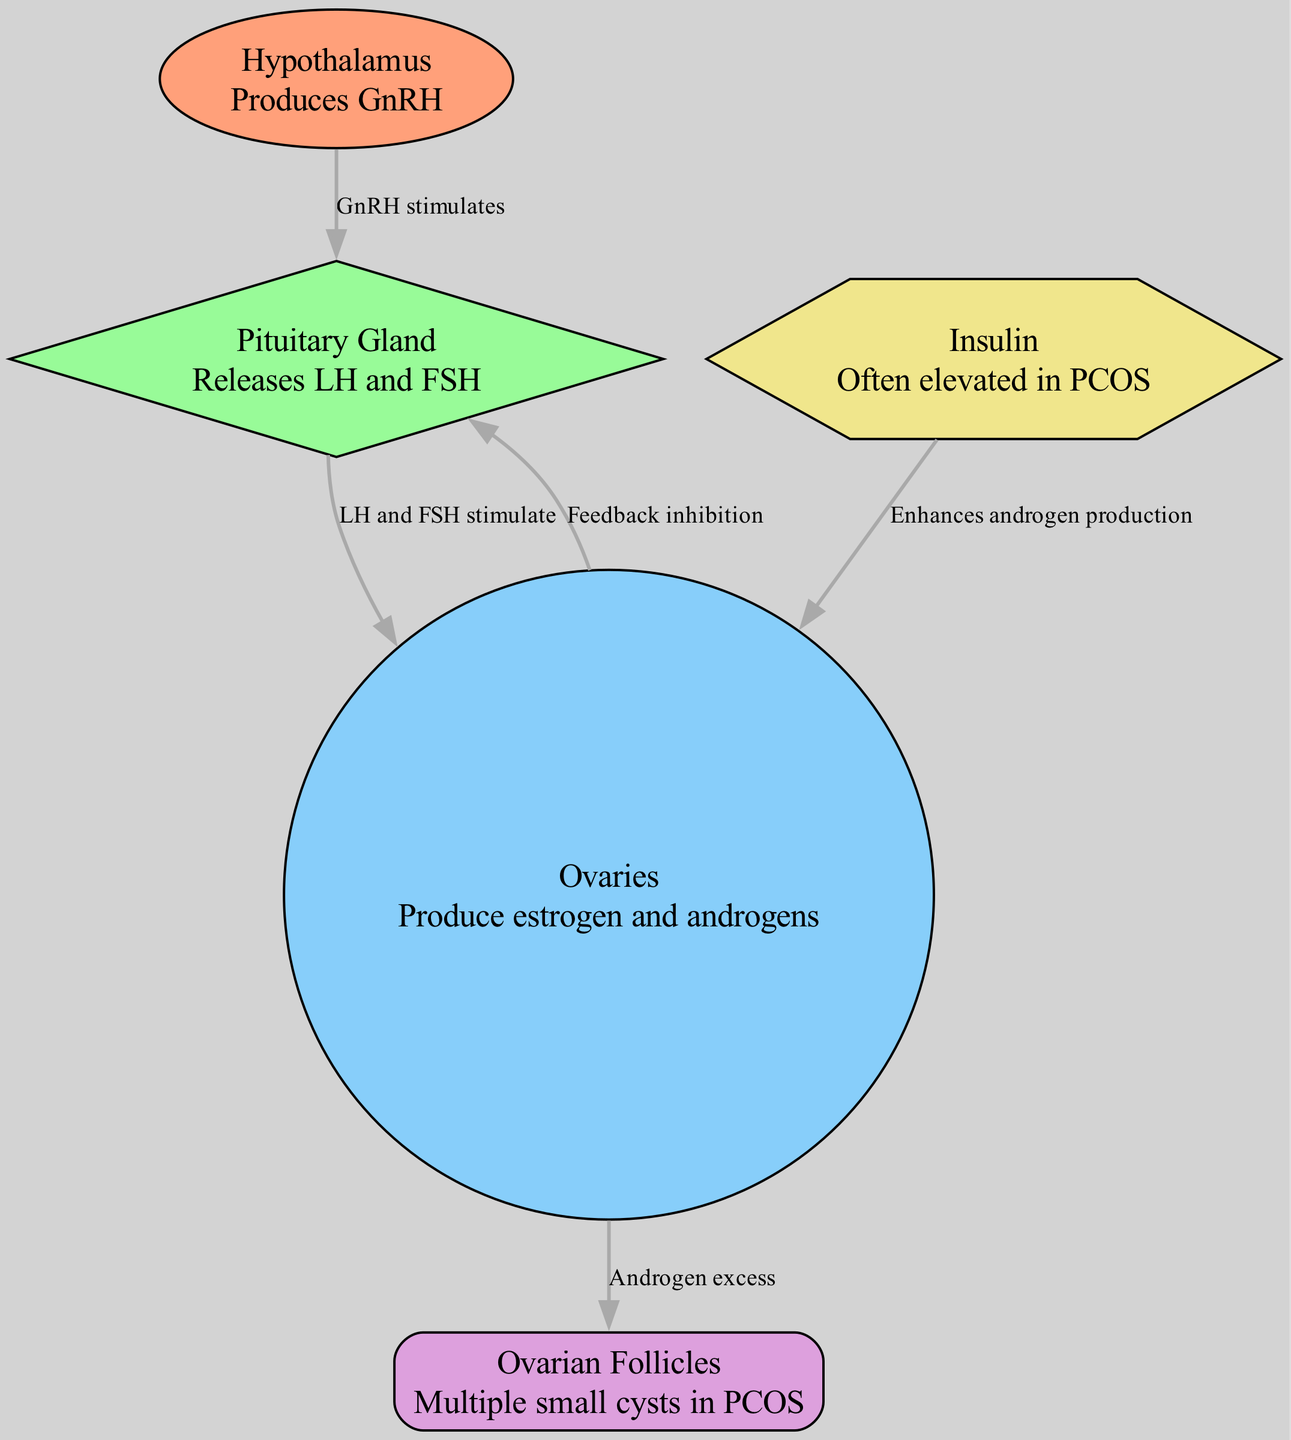What hormone does the hypothalamus produce? The diagram indicates that the hypothalamus produces GnRH. This is clearly stated in the node description for the hypothalamus.
Answer: GnRH How many nodes are present in the diagram? By counting the nodes listed in the diagram data, we find there are five nodes: hypothalamus, pituitary, ovaries, follicles, and insulin.
Answer: 5 Which glans releases LH and FSH? The arrow from the pituitary gland node indicates that it releases LH and FSH, as described in its node label.
Answer: Pituitary Gland What is the effect of GnRH on the pituitary gland? The diagram shows an arrow from the hypothalamus to the pituitary gland labeled "GnRH stimulates", indicating that GnRH has a stimulating effect on the pituitary gland.
Answer: Stimulates How do ovaries feedback to the pituitary gland? The arrow from the ovaries back to the pituitary gland is labeled "Feedback inhibition". This indicates that the ovaries provide feedback to inhibit the activity of the pituitary gland.
Answer: Feedback inhibition What enhances androgen production in the ovaries? The diagram indicates an arrow from insulin to the ovaries labeled "Enhances androgen production". This shows that insulin plays a role in increasing androgen levels in the ovaries.
Answer: Insulin What is the relationship between the ovaries and follicles in PCOS? The edge from the ovaries to the follicles is labeled "Androgen excess", which suggests that excess androgens produced by the ovaries contribute to the formation of multiple small cysts, referred to as follicles in PCOS.
Answer: Androgen excess What type of visual representation does this diagram portray? The diagram is a Biomedical Diagram that represents the hormonal interactions in the endocrine system, focusing on the relationships and feedback loops between the hypothalamus, pituitary gland, and ovaries.
Answer: Biomedical Diagram 